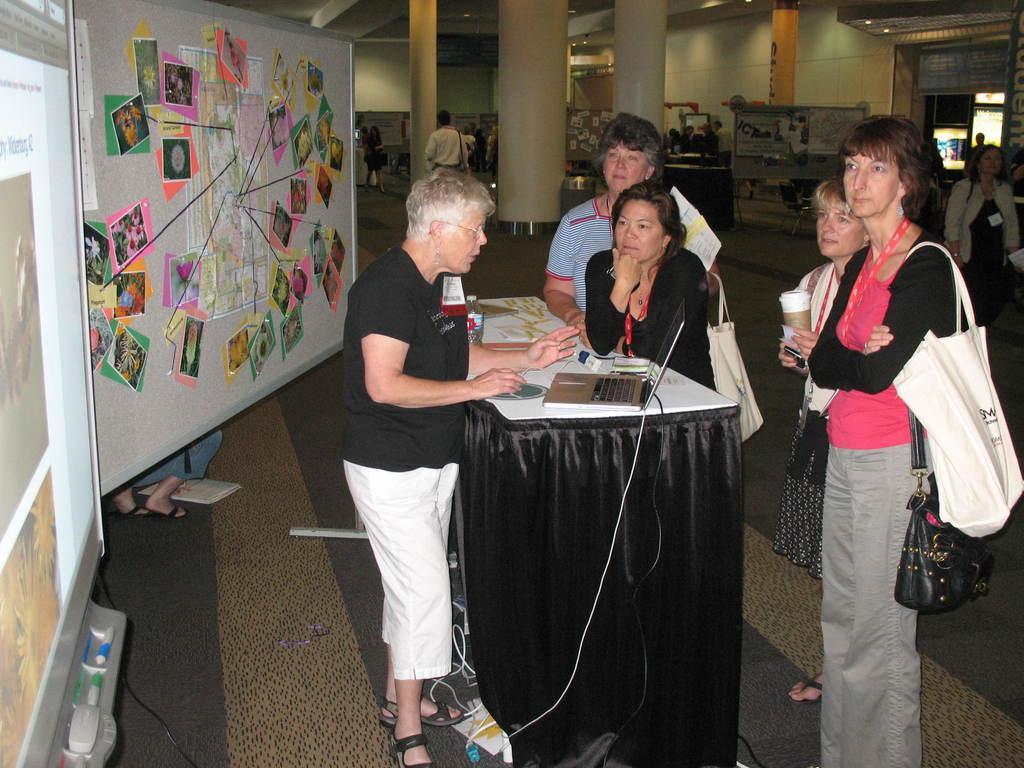Describe this image in one or two sentences. people are standing. the person at the left is operating the laptop. behind them there is a board on which papers are sticked. at the back there are pillars. 